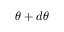<formula> <loc_0><loc_0><loc_500><loc_500>\theta + d \theta</formula> 